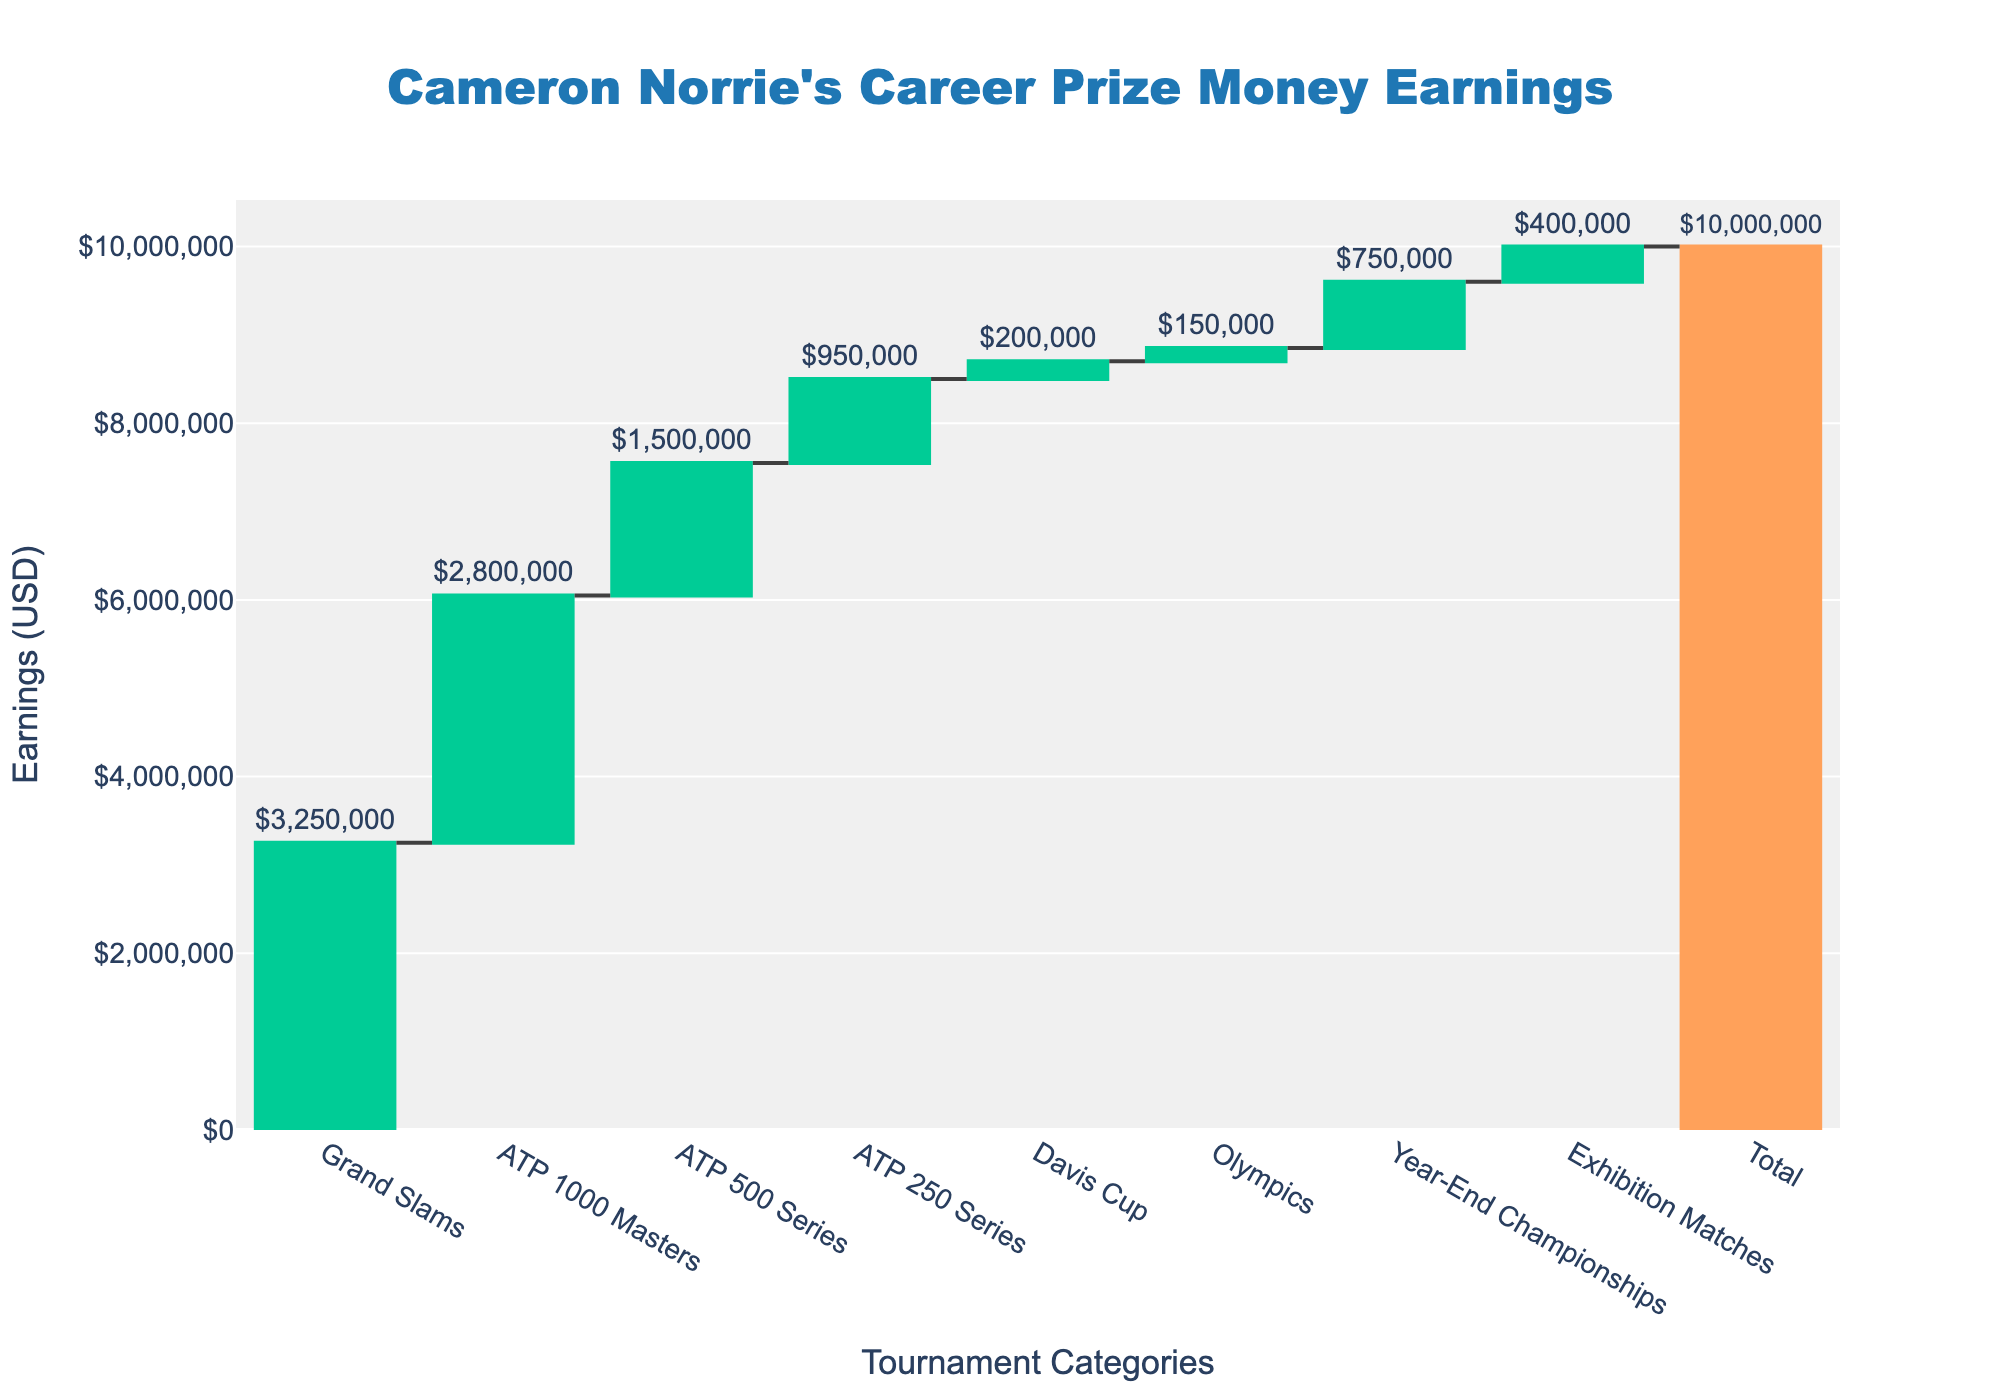What is the total prize money earnings of Cameron Norrie according to the chart? The total listed on the chart under "Total Career Earnings" is $10,000,000.
Answer: $10,000,000 Which tournament category contributed the most to Cameron Norrie's career prize money earnings? According to the chart, "Grand Slams" has the highest value at $3,250,000.
Answer: Grand Slams How much prize money did Cameron Norrie earn from ATP 1000 Masters and ATP 500 Series combined? From the chart, ATP 1000 Masters earned $2,800,000 and ATP 500 Series earned $1,500,000. Adding these amounts gives $2,800,000 + $1,500,000 = $4,300,000.
Answer: $4,300,000 What is the total prize money earned from the Davis Cup and Olympics combined? The chart indicates $200,000 from the Davis Cup and $150,000 from the Olympics. Summing these gives $200,000 + $150,000 = $350,000.
Answer: $350,000 Among the listed categories, which one contributed the least to Cameron Norrie's earnings? The chart shows the smallest contribution from the "Olympics" at $150,000.
Answer: Olympics Is the prize money from Exhibition Matches greater than the prize money from the Davis Cup? The chart lists $400,000 from Exhibition Matches and $200,000 from the Davis Cup. $400,000 is greater than $200,000.
Answer: Yes How much more did Cameron Norrie earn from Grand Slams compared to ATP 250 Series? The chart shows earnings of $3,250,000 from Grand Slams and $950,000 from ATP 250 Series. The difference is $3,250,000 - $950,000 = $2,300,000.
Answer: $2,300,000 What is the sum of Cameron Norrie's earnings from Year-End Championships and Exhibition Matches? The chart lists $750,000 from Year-End Championships and $400,000 from Exhibition Matches. The sum is $750,000 + $400,000 = $1,150,000.
Answer: $1,150,000 How many different tournament categories are listed in the chart (excluding the total)? The listed categories are Grand Slams, ATP 1000 Masters, ATP 500 Series, ATP 250 Series, Davis Cup, Olympics, Year-End Championships, and Exhibition Matches, making a total of 8 categories.
Answer: 8 